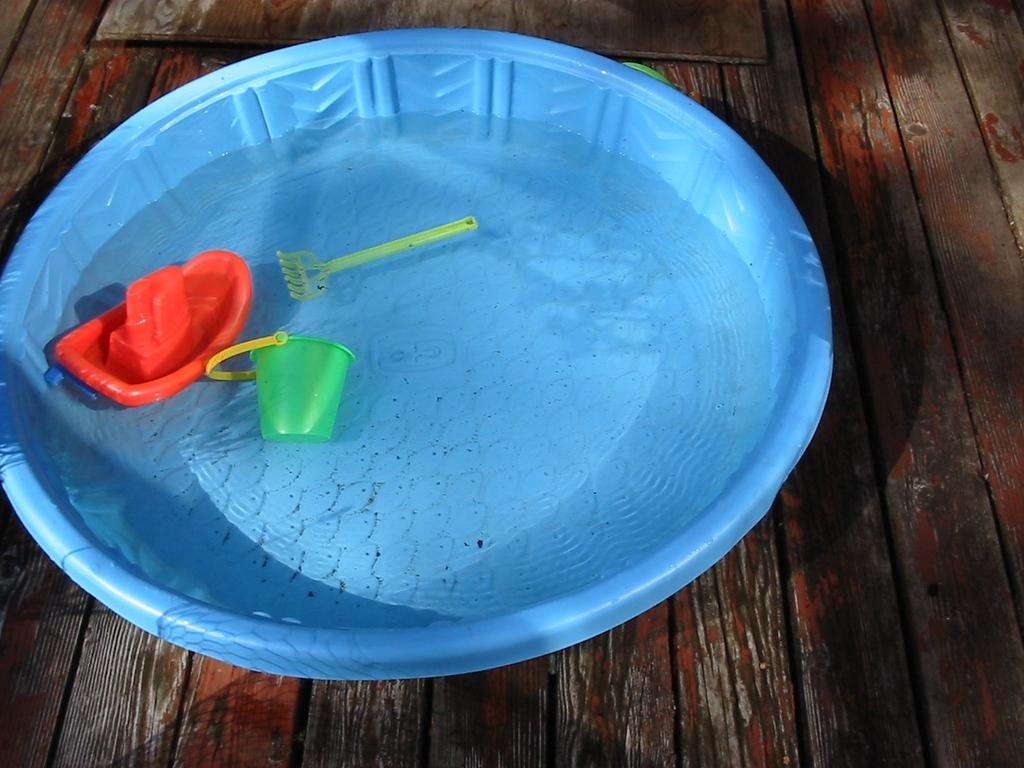What is the main piece of furniture in the image? There is a table in the image. What is placed on the table? There is a tub of water on the table. What is inside the tub of water? There are objects in the tub of water. What type of brain can be seen floating in the tub of water? There is no brain present in the image; it only shows a tub of water with objects inside. 